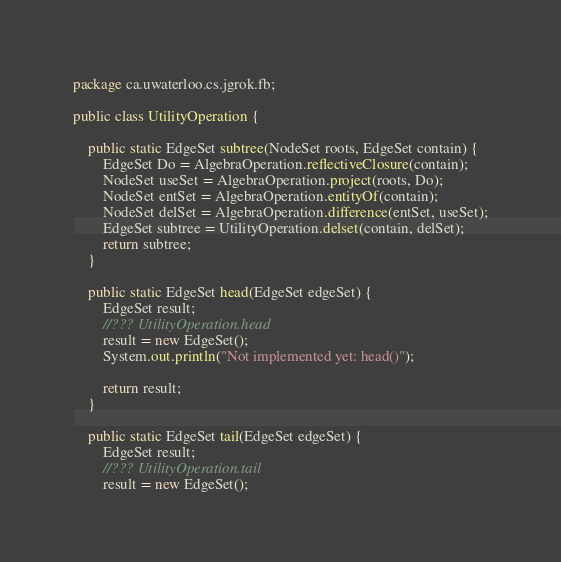<code> <loc_0><loc_0><loc_500><loc_500><_Java_>package ca.uwaterloo.cs.jgrok.fb;

public class UtilityOperation {
    
    public static EdgeSet subtree(NodeSet roots, EdgeSet contain) {
        EdgeSet Do = AlgebraOperation.reflectiveClosure(contain);
        NodeSet useSet = AlgebraOperation.project(roots, Do);
        NodeSet entSet = AlgebraOperation.entityOf(contain);
        NodeSet delSet = AlgebraOperation.difference(entSet, useSet);
        EdgeSet subtree = UtilityOperation.delset(contain, delSet);
        return subtree;
    }
    
    public static EdgeSet head(EdgeSet edgeSet) {
        EdgeSet result;
        //??? UtilityOperation.head
        result = new EdgeSet();
        System.out.println("Not implemented yet: head()");
        
        return result;
    }
    
    public static EdgeSet tail(EdgeSet edgeSet) {
        EdgeSet result;
        //??? UtilityOperation.tail
        result = new EdgeSet();</code> 